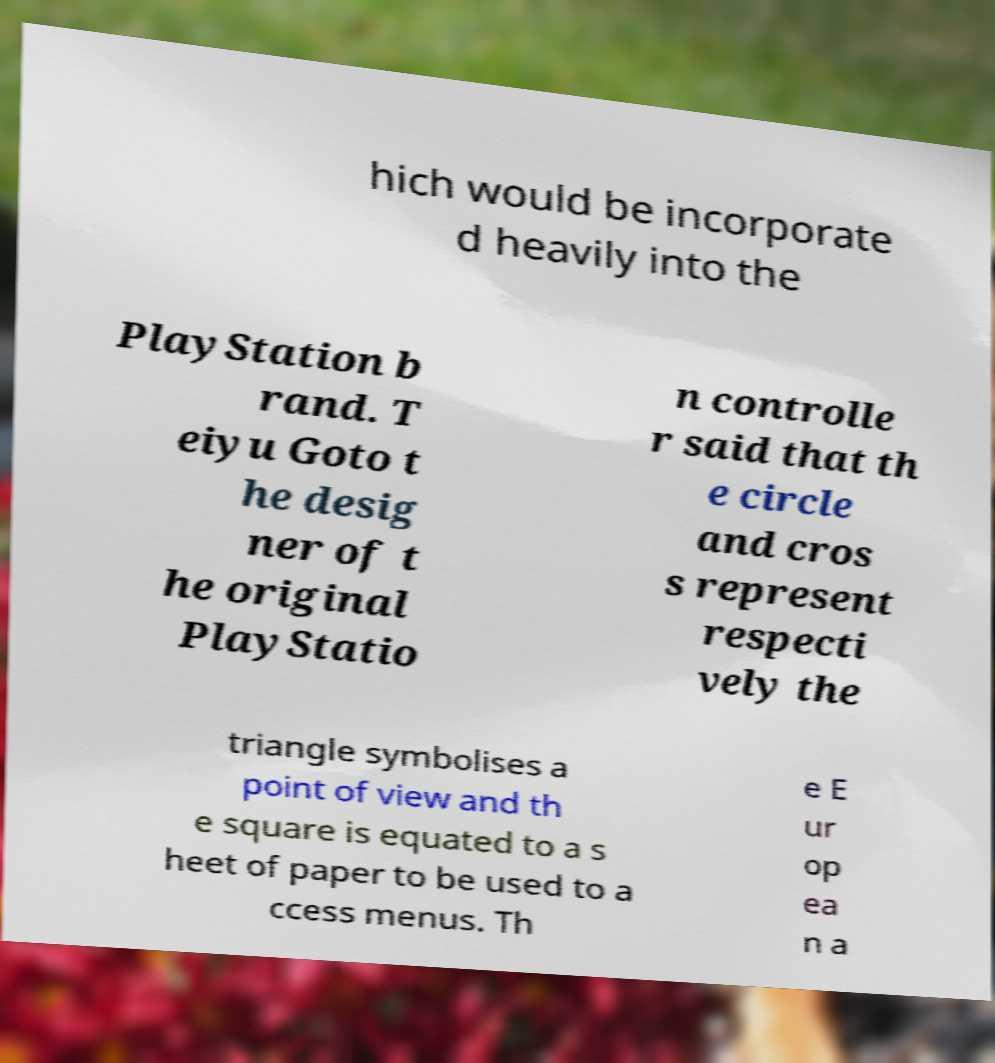Please read and relay the text visible in this image. What does it say? hich would be incorporate d heavily into the PlayStation b rand. T eiyu Goto t he desig ner of t he original PlayStatio n controlle r said that th e circle and cros s represent respecti vely the triangle symbolises a point of view and th e square is equated to a s heet of paper to be used to a ccess menus. Th e E ur op ea n a 